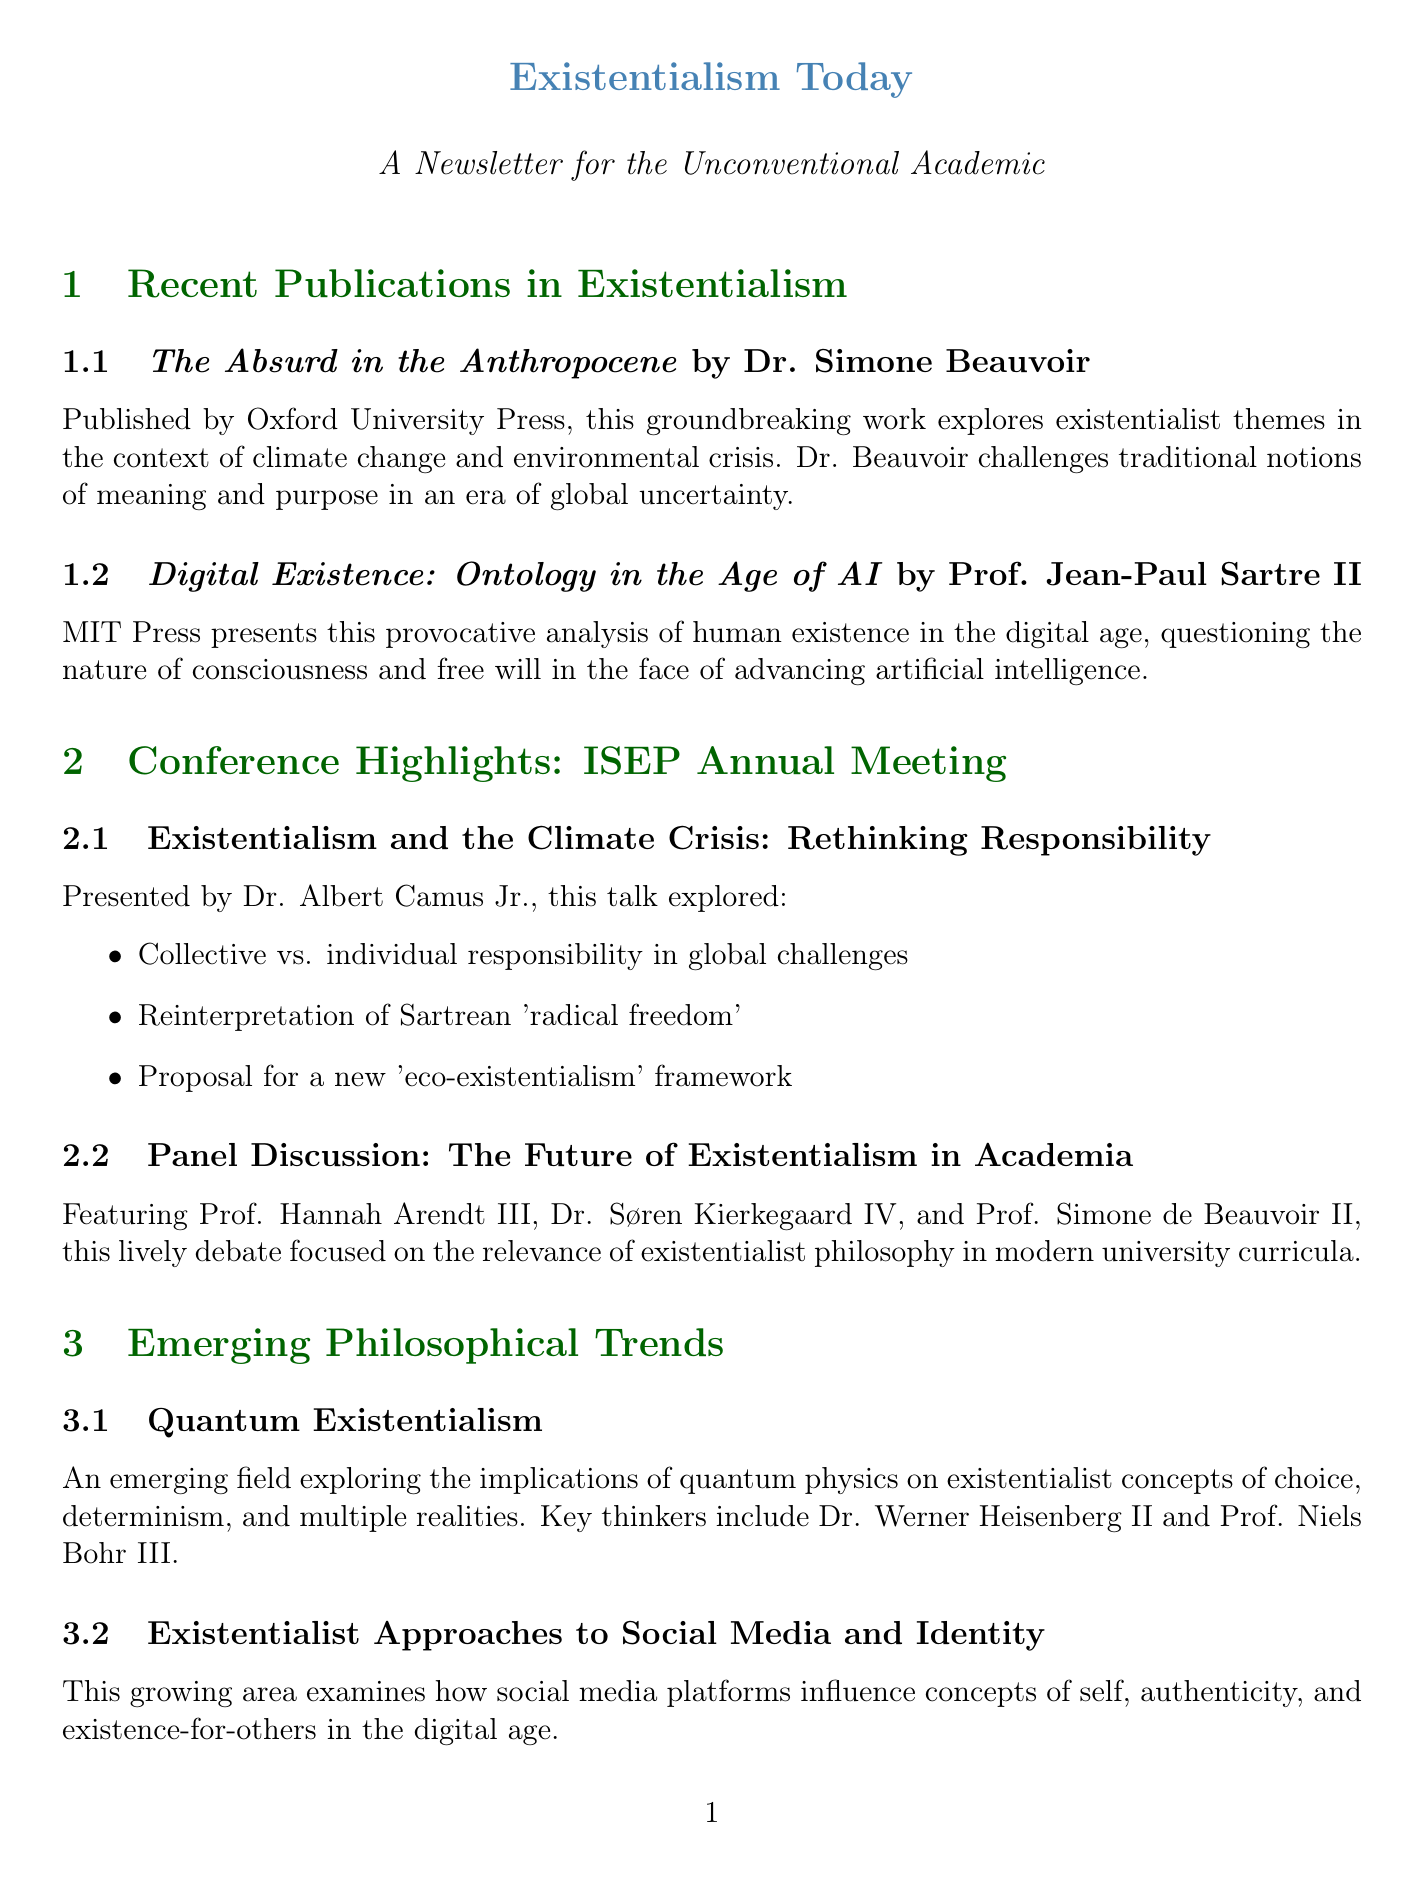What is the title of Dr. Simone Beauvoir's book? The title of Dr. Simone Beauvoir's book is provided in the "Recent Publications in Existentialism" section.
Answer: The Absurd in the Anthropocene Who published "Digital Existence: Ontology in the Age of AI"? The publisher of the book is mentioned next to its title in the newsletter.
Answer: MIT Press What is a key theme discussed in Dr. Albert Camus Jr.'s presentation? The key points of his presentation are outlined in bullet form, highlighting the major themes discussed.
Answer: Rethinking Responsibility Which philosophical trend explores the implications of quantum physics? The newsletter lists emerging philosophical trends along with their descriptions to identify each trend.
Answer: Quantum Existentialism Who directed the film "The Sisyphus Project"? The director's name is included in the summary of the film section under Popular Culture.
Answer: Charlie Kaufman Which conference is highlighted in the newsletter? The conference is specifically mentioned in the title of the conference highlights section of the document.
Answer: International Society for Existential Philosophy (ISEP) What type of media is "Existential Crisis Simulator"? The medium is introduced in the Popular Culture section where various media forms are discussed.
Answer: Video Game How many key thinkers are mentioned in the Quantum Existentialism trend? This information requires counting the number of individuals listed under that trend.
Answer: Two 